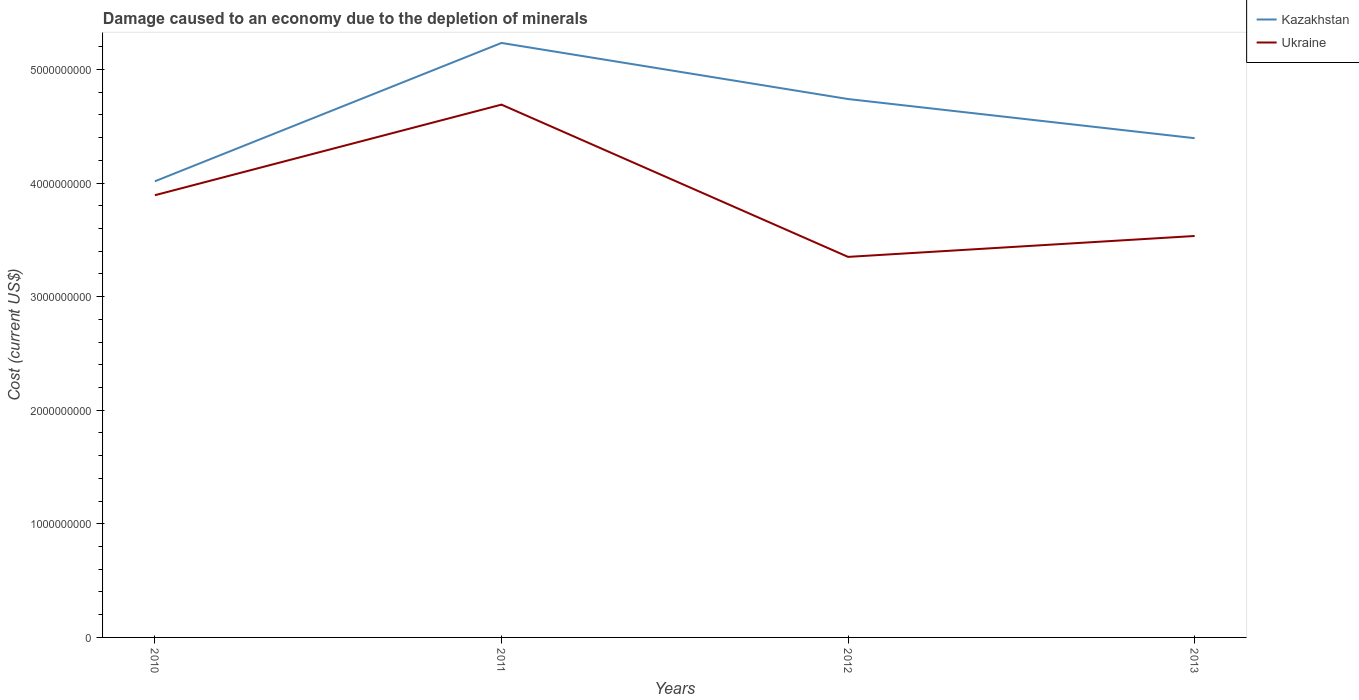Does the line corresponding to Kazakhstan intersect with the line corresponding to Ukraine?
Keep it short and to the point. No. Is the number of lines equal to the number of legend labels?
Your answer should be very brief. Yes. Across all years, what is the maximum cost of damage caused due to the depletion of minerals in Ukraine?
Make the answer very short. 3.35e+09. In which year was the cost of damage caused due to the depletion of minerals in Kazakhstan maximum?
Make the answer very short. 2010. What is the total cost of damage caused due to the depletion of minerals in Ukraine in the graph?
Provide a short and direct response. -1.84e+08. What is the difference between the highest and the second highest cost of damage caused due to the depletion of minerals in Ukraine?
Ensure brevity in your answer.  1.34e+09. How many lines are there?
Your answer should be compact. 2. How many years are there in the graph?
Ensure brevity in your answer.  4. Does the graph contain grids?
Offer a very short reply. No. What is the title of the graph?
Your answer should be very brief. Damage caused to an economy due to the depletion of minerals. Does "Mongolia" appear as one of the legend labels in the graph?
Provide a short and direct response. No. What is the label or title of the Y-axis?
Your answer should be very brief. Cost (current US$). What is the Cost (current US$) in Kazakhstan in 2010?
Your answer should be compact. 4.02e+09. What is the Cost (current US$) in Ukraine in 2010?
Give a very brief answer. 3.89e+09. What is the Cost (current US$) of Kazakhstan in 2011?
Keep it short and to the point. 5.23e+09. What is the Cost (current US$) of Ukraine in 2011?
Provide a short and direct response. 4.69e+09. What is the Cost (current US$) in Kazakhstan in 2012?
Make the answer very short. 4.74e+09. What is the Cost (current US$) of Ukraine in 2012?
Give a very brief answer. 3.35e+09. What is the Cost (current US$) in Kazakhstan in 2013?
Your answer should be compact. 4.39e+09. What is the Cost (current US$) of Ukraine in 2013?
Provide a succinct answer. 3.53e+09. Across all years, what is the maximum Cost (current US$) of Kazakhstan?
Keep it short and to the point. 5.23e+09. Across all years, what is the maximum Cost (current US$) in Ukraine?
Provide a short and direct response. 4.69e+09. Across all years, what is the minimum Cost (current US$) of Kazakhstan?
Ensure brevity in your answer.  4.02e+09. Across all years, what is the minimum Cost (current US$) in Ukraine?
Keep it short and to the point. 3.35e+09. What is the total Cost (current US$) in Kazakhstan in the graph?
Your answer should be very brief. 1.84e+1. What is the total Cost (current US$) in Ukraine in the graph?
Provide a succinct answer. 1.55e+1. What is the difference between the Cost (current US$) in Kazakhstan in 2010 and that in 2011?
Your answer should be compact. -1.22e+09. What is the difference between the Cost (current US$) of Ukraine in 2010 and that in 2011?
Offer a terse response. -7.97e+08. What is the difference between the Cost (current US$) of Kazakhstan in 2010 and that in 2012?
Your answer should be compact. -7.24e+08. What is the difference between the Cost (current US$) of Ukraine in 2010 and that in 2012?
Provide a short and direct response. 5.43e+08. What is the difference between the Cost (current US$) of Kazakhstan in 2010 and that in 2013?
Provide a short and direct response. -3.79e+08. What is the difference between the Cost (current US$) of Ukraine in 2010 and that in 2013?
Keep it short and to the point. 3.59e+08. What is the difference between the Cost (current US$) in Kazakhstan in 2011 and that in 2012?
Provide a short and direct response. 4.94e+08. What is the difference between the Cost (current US$) in Ukraine in 2011 and that in 2012?
Provide a short and direct response. 1.34e+09. What is the difference between the Cost (current US$) of Kazakhstan in 2011 and that in 2013?
Your answer should be compact. 8.38e+08. What is the difference between the Cost (current US$) in Ukraine in 2011 and that in 2013?
Your response must be concise. 1.16e+09. What is the difference between the Cost (current US$) of Kazakhstan in 2012 and that in 2013?
Offer a terse response. 3.45e+08. What is the difference between the Cost (current US$) of Ukraine in 2012 and that in 2013?
Offer a very short reply. -1.84e+08. What is the difference between the Cost (current US$) in Kazakhstan in 2010 and the Cost (current US$) in Ukraine in 2011?
Offer a terse response. -6.75e+08. What is the difference between the Cost (current US$) in Kazakhstan in 2010 and the Cost (current US$) in Ukraine in 2012?
Provide a succinct answer. 6.65e+08. What is the difference between the Cost (current US$) in Kazakhstan in 2010 and the Cost (current US$) in Ukraine in 2013?
Give a very brief answer. 4.82e+08. What is the difference between the Cost (current US$) in Kazakhstan in 2011 and the Cost (current US$) in Ukraine in 2012?
Provide a succinct answer. 1.88e+09. What is the difference between the Cost (current US$) of Kazakhstan in 2011 and the Cost (current US$) of Ukraine in 2013?
Provide a succinct answer. 1.70e+09. What is the difference between the Cost (current US$) of Kazakhstan in 2012 and the Cost (current US$) of Ukraine in 2013?
Ensure brevity in your answer.  1.21e+09. What is the average Cost (current US$) of Kazakhstan per year?
Provide a short and direct response. 4.60e+09. What is the average Cost (current US$) of Ukraine per year?
Provide a short and direct response. 3.87e+09. In the year 2010, what is the difference between the Cost (current US$) in Kazakhstan and Cost (current US$) in Ukraine?
Give a very brief answer. 1.23e+08. In the year 2011, what is the difference between the Cost (current US$) in Kazakhstan and Cost (current US$) in Ukraine?
Ensure brevity in your answer.  5.43e+08. In the year 2012, what is the difference between the Cost (current US$) in Kazakhstan and Cost (current US$) in Ukraine?
Your response must be concise. 1.39e+09. In the year 2013, what is the difference between the Cost (current US$) in Kazakhstan and Cost (current US$) in Ukraine?
Offer a terse response. 8.61e+08. What is the ratio of the Cost (current US$) of Kazakhstan in 2010 to that in 2011?
Provide a succinct answer. 0.77. What is the ratio of the Cost (current US$) of Ukraine in 2010 to that in 2011?
Provide a short and direct response. 0.83. What is the ratio of the Cost (current US$) in Kazakhstan in 2010 to that in 2012?
Your answer should be compact. 0.85. What is the ratio of the Cost (current US$) in Ukraine in 2010 to that in 2012?
Give a very brief answer. 1.16. What is the ratio of the Cost (current US$) in Kazakhstan in 2010 to that in 2013?
Keep it short and to the point. 0.91. What is the ratio of the Cost (current US$) of Ukraine in 2010 to that in 2013?
Provide a succinct answer. 1.1. What is the ratio of the Cost (current US$) of Kazakhstan in 2011 to that in 2012?
Offer a terse response. 1.1. What is the ratio of the Cost (current US$) of Ukraine in 2011 to that in 2012?
Offer a very short reply. 1.4. What is the ratio of the Cost (current US$) in Kazakhstan in 2011 to that in 2013?
Your response must be concise. 1.19. What is the ratio of the Cost (current US$) in Ukraine in 2011 to that in 2013?
Offer a very short reply. 1.33. What is the ratio of the Cost (current US$) of Kazakhstan in 2012 to that in 2013?
Your response must be concise. 1.08. What is the ratio of the Cost (current US$) of Ukraine in 2012 to that in 2013?
Your answer should be very brief. 0.95. What is the difference between the highest and the second highest Cost (current US$) in Kazakhstan?
Your response must be concise. 4.94e+08. What is the difference between the highest and the second highest Cost (current US$) of Ukraine?
Offer a terse response. 7.97e+08. What is the difference between the highest and the lowest Cost (current US$) of Kazakhstan?
Make the answer very short. 1.22e+09. What is the difference between the highest and the lowest Cost (current US$) in Ukraine?
Provide a succinct answer. 1.34e+09. 